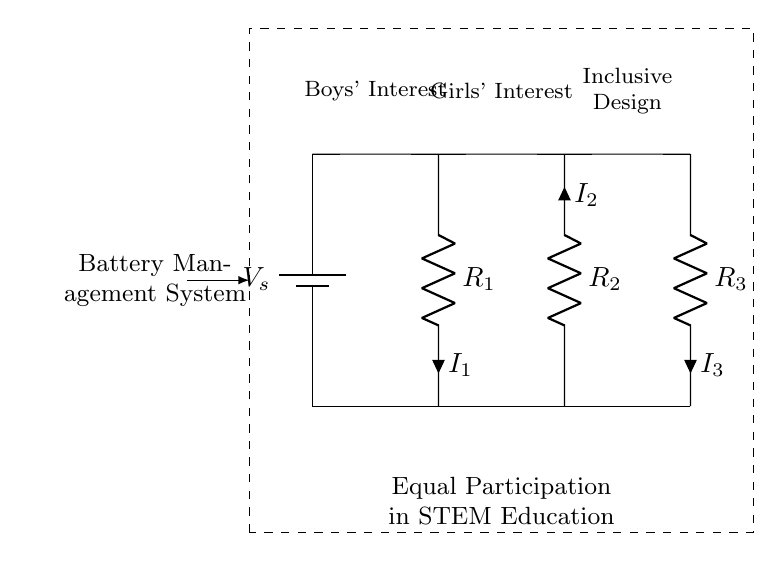What is the power supply in this circuit? The power supply is represented by the battery labeled V_s, which provides the voltage necessary for the circuit to function.
Answer: V_s What are the resistance values in the circuit? The circuit contains three resistors indicated as R_1, R_2, and R_3, but their specific values are not given in the diagram. They are shown generically as symbols for resistors.
Answer: R_1, R_2, R_3 How many current paths are there in this circuit? The circuit has three current paths, which are represented by the three resistors branching out from the main voltage source.
Answer: Three What does each branch represent in terms of gender interests? Each branch of the current divider represents different gender interests: Boys' Interest for R_1, Girls' Interest for R_2, and Inclusive Design for R_3, indicating a focus on diverse engagement in STEM education.
Answer: Boys' Interest, Girls' Interest, Inclusive Design What is the purpose of the battery management system in this circuit? The battery management system, encapsulated by the dashed rectangle, is to ensure that the power supply operates effectively, likely enhancing student engagement in STEM festivals and promoting equal participation by managing the voltage and current distribution among diverse interests.
Answer: Promote equal participation What is the configuration of resistors in this circuit? The resistors are arranged in a parallel configuration, which is characteristic of a current divider where the current divides among the paths based on the resistance values.
Answer: Parallel What is the implication of 'Equal Participation in STEM Education' in the context of this circuit? The text 'Equal Participation in STEM Education' below the circuit indicates that the design and operation of the circuit are intended to foster inclusivity and encourage engagement from all genders in educational settings.
Answer: Inclusivity in education 